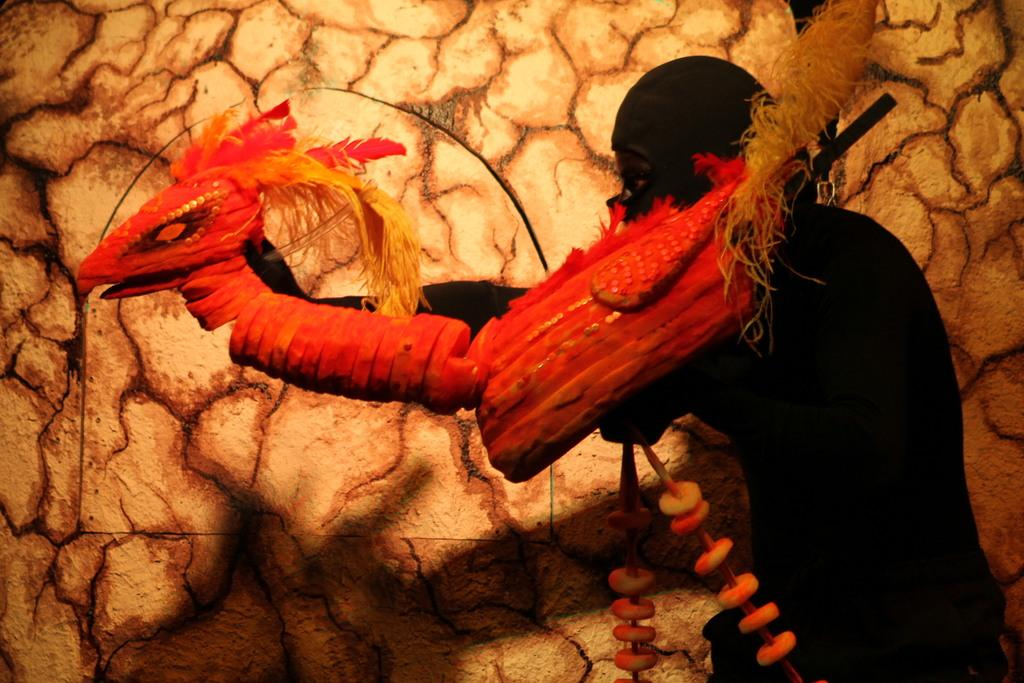What is the main subject of the image? There is an illustration in the image. What is your aunt doing in the winter scene depicted in the illustration? There is no mention of an aunt or a winter scene in the provided fact, and therefore no such activity can be observed. 